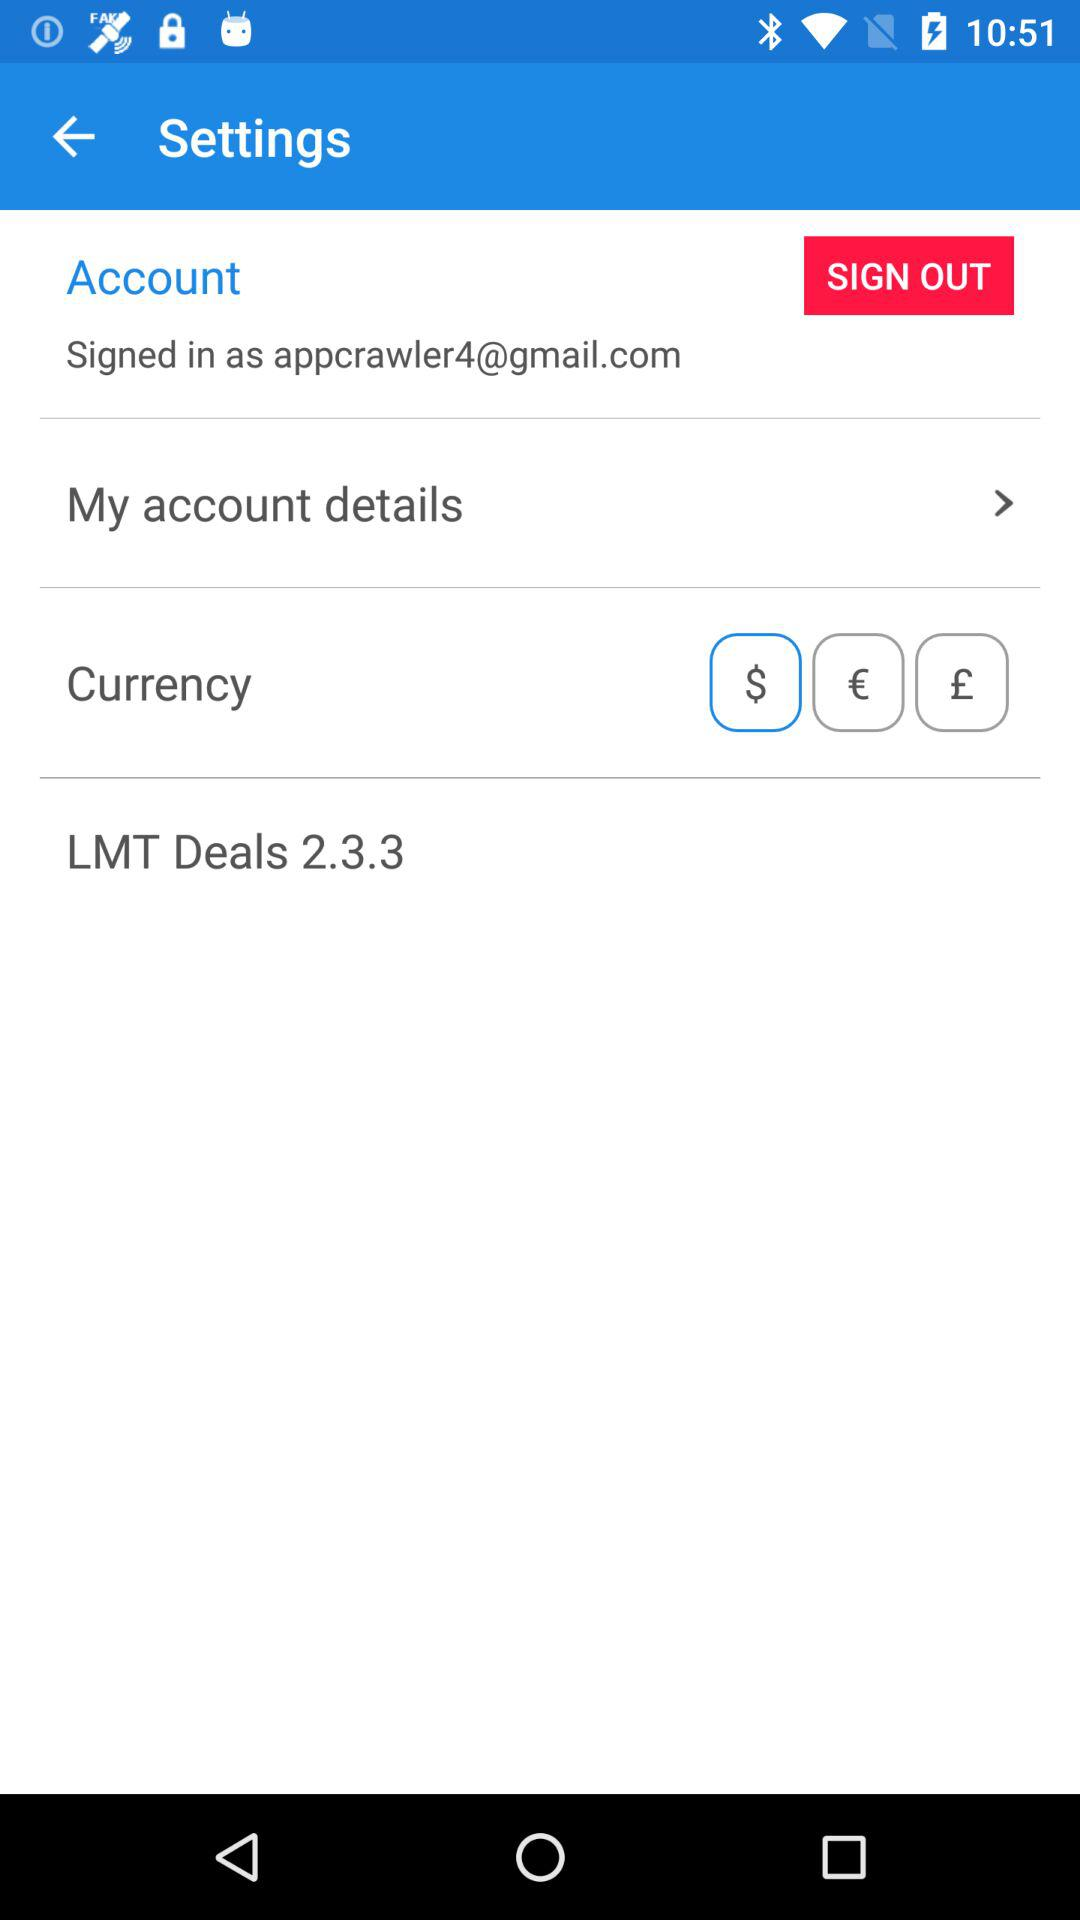What is the selected currency? The selected currency is $. 